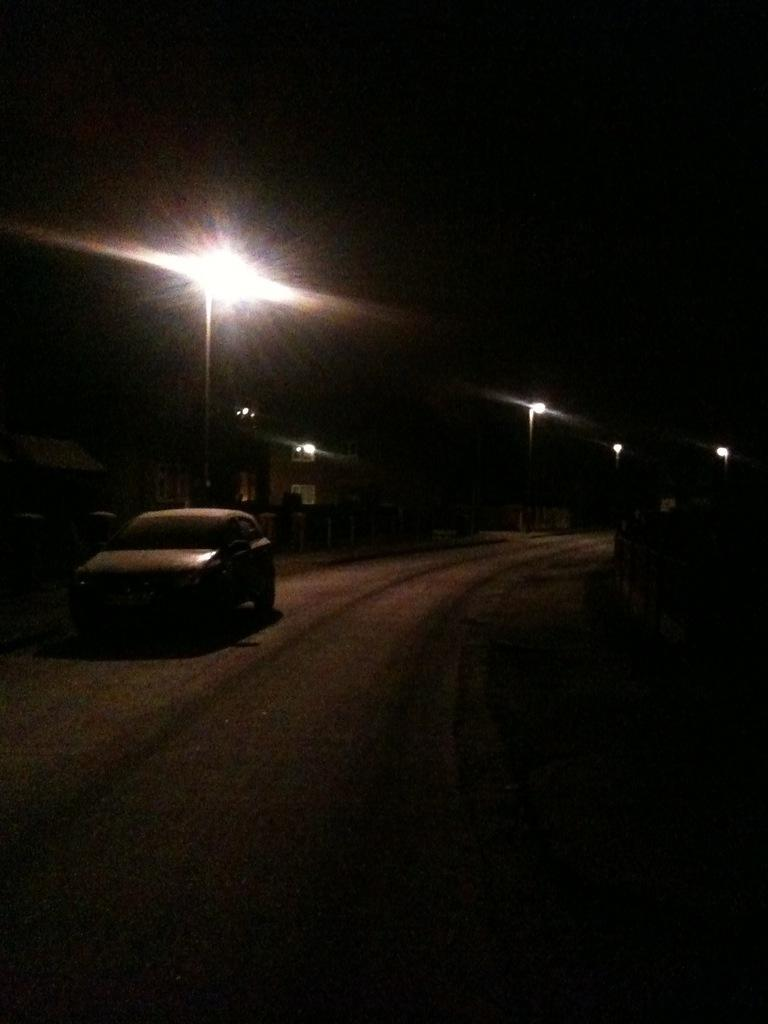What is the main subject of the image? The main subject of the image is a car on the road. What can be seen on the left side of the image? There are buildings on the left side of the image. What is visible at the top of the image? There are lights visible at the top of the image. Is there a scarecrow standing in front of the car in the image? No, there is no scarecrow present in the image. 